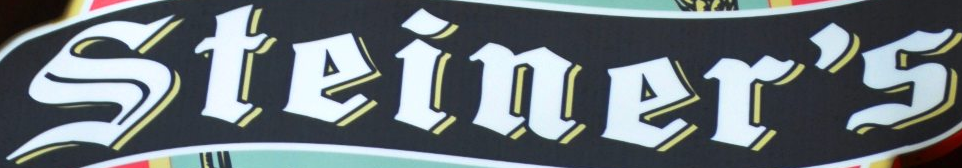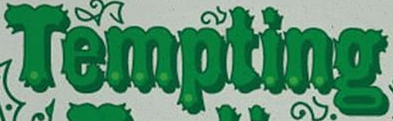Identify the words shown in these images in order, separated by a semicolon. Steiner's; Tempting 